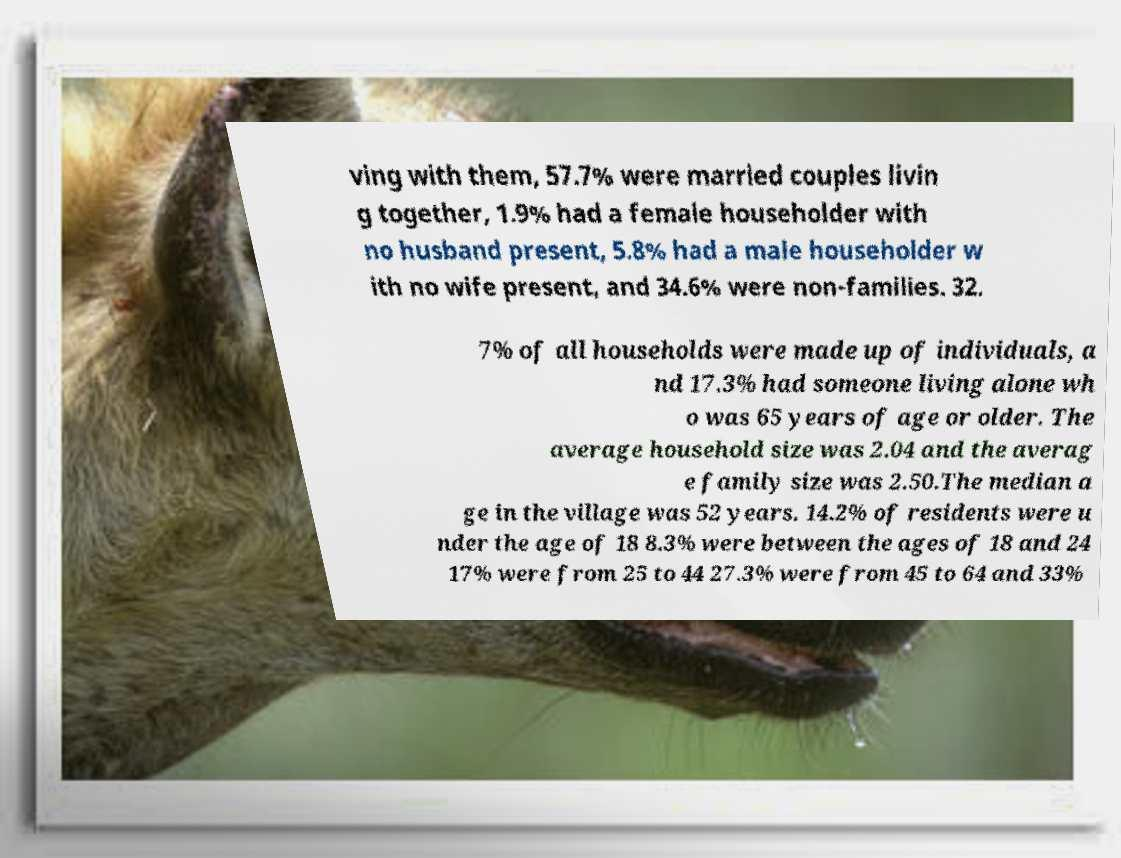What messages or text are displayed in this image? I need them in a readable, typed format. ving with them, 57.7% were married couples livin g together, 1.9% had a female householder with no husband present, 5.8% had a male householder w ith no wife present, and 34.6% were non-families. 32. 7% of all households were made up of individuals, a nd 17.3% had someone living alone wh o was 65 years of age or older. The average household size was 2.04 and the averag e family size was 2.50.The median a ge in the village was 52 years. 14.2% of residents were u nder the age of 18 8.3% were between the ages of 18 and 24 17% were from 25 to 44 27.3% were from 45 to 64 and 33% 